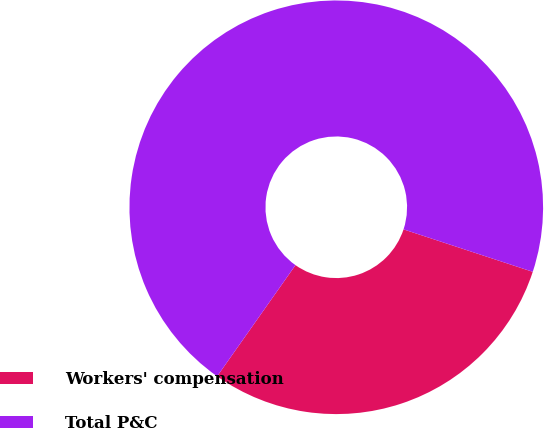<chart> <loc_0><loc_0><loc_500><loc_500><pie_chart><fcel>Workers' compensation<fcel>Total P&C<nl><fcel>29.72%<fcel>70.28%<nl></chart> 